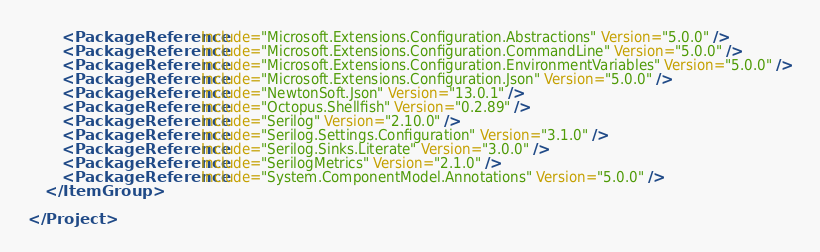<code> <loc_0><loc_0><loc_500><loc_500><_XML_>		<PackageReference Include="Microsoft.Extensions.Configuration.Abstractions" Version="5.0.0" />
		<PackageReference Include="Microsoft.Extensions.Configuration.CommandLine" Version="5.0.0" />
		<PackageReference Include="Microsoft.Extensions.Configuration.EnvironmentVariables" Version="5.0.0" />
		<PackageReference Include="Microsoft.Extensions.Configuration.Json" Version="5.0.0" />
		<PackageReference Include="NewtonSoft.Json" Version="13.0.1" />
		<PackageReference Include="Octopus.Shellfish" Version="0.2.89" />
		<PackageReference Include="Serilog" Version="2.10.0" />
		<PackageReference Include="Serilog.Settings.Configuration" Version="3.1.0" />
		<PackageReference Include="Serilog.Sinks.Literate" Version="3.0.0" />
		<PackageReference Include="SerilogMetrics" Version="2.1.0" />
		<PackageReference Include="System.ComponentModel.Annotations" Version="5.0.0" />
	</ItemGroup>

</Project>
</code> 